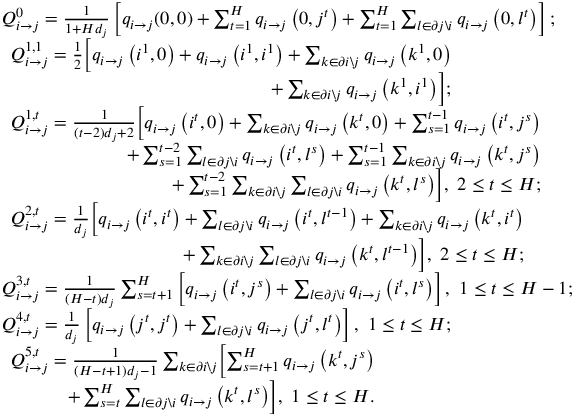<formula> <loc_0><loc_0><loc_500><loc_500>\begin{array} { r l } & { Q _ { i \rightarrow j } ^ { 0 } = \frac { 1 } { 1 + H d _ { j } } \left [ q _ { i \rightarrow j } ( 0 , 0 ) + \sum _ { t = 1 } ^ { H } q _ { i \rightarrow j } \left ( 0 , j ^ { t } \right ) + \sum _ { t = 1 } ^ { H } \sum _ { l \in \partial j \ i } q _ { i \rightarrow j } \left ( 0 , l ^ { t } \right ) \right ] ; } \\ & { \begin{array} { r l } { Q _ { i \rightarrow j } ^ { 1 , 1 } = \frac { 1 } { 2 } \left [ q _ { i \rightarrow j } \left ( i ^ { 1 } , 0 \right ) + q _ { i \rightarrow j } \left ( i ^ { 1 } , i ^ { 1 } \right ) + \sum _ { k \in \partial i \ j } q _ { i \rightarrow j } \left ( k ^ { 1 } , 0 \right ) } \\ { + \sum _ { k \in \partial i \ j } q _ { i \rightarrow j } \left ( k ^ { 1 } , i ^ { 1 } \right ) \right ] ; } \end{array} } \\ & { \begin{array} { r l } { Q _ { i \rightarrow j } ^ { 1 , t } = \frac { 1 } { ( t - 2 ) d _ { j } + 2 } \left [ q _ { i \rightarrow j } \left ( i ^ { t } , 0 \right ) + \sum _ { k \in \partial i \ j } q _ { i \rightarrow j } \left ( k ^ { t } , 0 \right ) + \sum _ { s = 1 } ^ { t - 1 } q _ { i \rightarrow j } \left ( i ^ { t } , j ^ { s } \right ) } \\ { + \sum _ { s = 1 } ^ { t - 2 } \sum _ { l \in \partial j \ i } q _ { i \rightarrow j } \left ( i ^ { t } , l ^ { s } \right ) + \sum _ { s = 1 } ^ { t - 1 } \sum _ { k \in \partial i \ j } q _ { i \rightarrow j } \left ( k ^ { t } , j ^ { s } \right ) } \\ { + \sum _ { s = 1 } ^ { t - 2 } \sum _ { k \in \partial i \ j } \sum _ { l \in \partial j \ i } q _ { i \rightarrow j } \left ( k ^ { t } , l ^ { s } \right ) \right ] , \ 2 \leq t \leq H ; } \end{array} } \\ & { \begin{array} { r l } { Q _ { i \rightarrow j } ^ { 2 , t } = \frac { 1 } { d _ { j } } \left [ q _ { i \rightarrow j } \left ( i ^ { t } , i ^ { t } \right ) + \sum _ { l \in \partial j \ i } q _ { i \rightarrow j } \left ( i ^ { t } , l ^ { t - 1 } \right ) + \sum _ { k \in \partial i \ j } q _ { i \rightarrow j } \left ( k ^ { t } , i ^ { t } \right ) } \\ { + \sum _ { k \in \partial i \ j } \sum _ { l \in \partial j \ i } q _ { i \rightarrow j } \left ( k ^ { t } , l ^ { t - 1 } \right ) \right ] , \ 2 \leq t \leq H ; } \end{array} } \\ & { Q _ { i \rightarrow j } ^ { 3 , t } = \frac { 1 } { ( H - t ) d _ { j } } \sum _ { s = t + 1 } ^ { H } \left [ q _ { i \rightarrow j } \left ( i ^ { t } , j ^ { s } \right ) + \sum _ { l \in \partial j \ i } q _ { i \rightarrow j } \left ( i ^ { t } , l ^ { s } \right ) \right ] , \ 1 \leq t \leq H - 1 ; } \\ & { Q _ { i \rightarrow j } ^ { 4 , t } = \frac { 1 } { d _ { j } } \left [ q _ { i \rightarrow j } \left ( j ^ { t } , j ^ { t } \right ) + \sum _ { l \in \partial j \ i } q _ { i \rightarrow j } \left ( j ^ { t } , l ^ { t } \right ) \right ] , \ 1 \leq t \leq H ; } \\ & { \begin{array} { r l } { Q _ { i \rightarrow j } ^ { 5 , t } = \frac { 1 } { ( H - t + 1 ) d _ { j } - 1 } \sum _ { k \in \partial i \ j } \left [ \sum _ { s = t + 1 } ^ { H } q _ { i \rightarrow j } \left ( k ^ { t } , j ^ { s } \right ) } \\ { + \sum _ { s = t } ^ { H } \sum _ { l \in \partial j \ i } q _ { i \rightarrow j } \left ( k ^ { t } , l ^ { s } \right ) \right ] , \ 1 \leq t \leq H . } \end{array} } \end{array}</formula> 